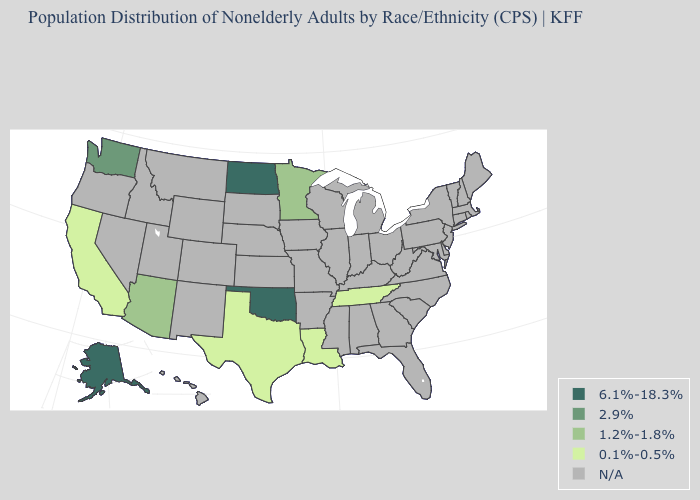What is the value of West Virginia?
Concise answer only. N/A. Is the legend a continuous bar?
Answer briefly. No. What is the value of South Dakota?
Concise answer only. N/A. What is the value of Virginia?
Short answer required. N/A. Name the states that have a value in the range 2.9%?
Quick response, please. Washington. What is the value of North Dakota?
Be succinct. 6.1%-18.3%. Name the states that have a value in the range 2.9%?
Be succinct. Washington. Name the states that have a value in the range 1.2%-1.8%?
Be succinct. Arizona, Minnesota. Does Alaska have the lowest value in the USA?
Concise answer only. No. What is the lowest value in the USA?
Write a very short answer. 0.1%-0.5%. Name the states that have a value in the range 1.2%-1.8%?
Quick response, please. Arizona, Minnesota. 